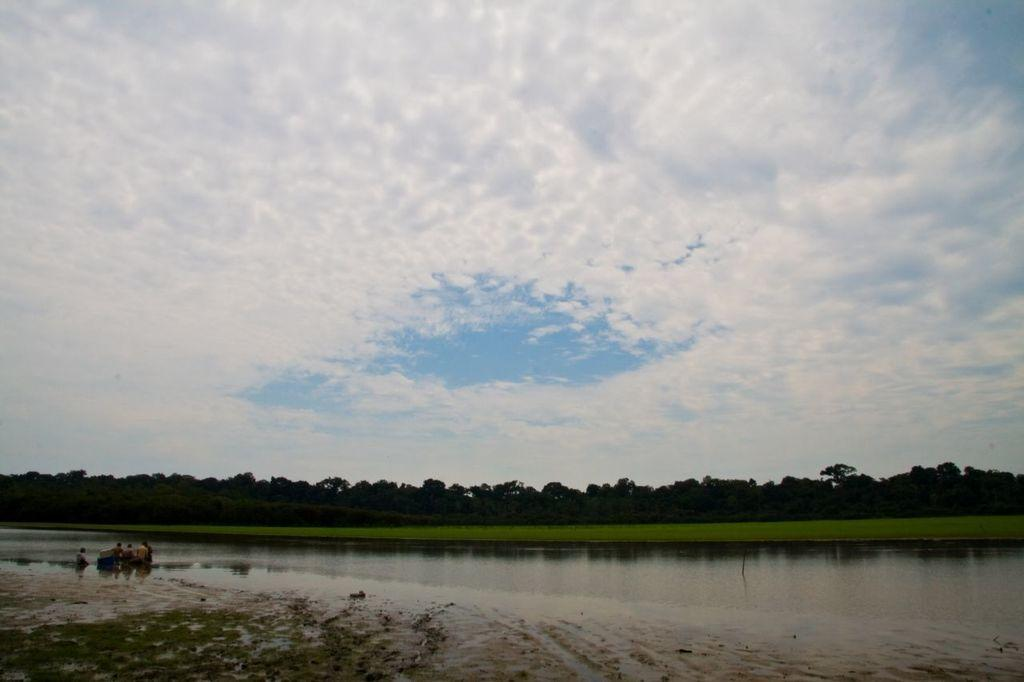What is present in the foreground of the image? In the foreground of the image, there is mud, grass, and water. What are the people in the image doing? There are persons in the water, suggesting they might be swimming or playing. What can be seen in the background of the image? In the background of the image, there is grass, trees, and sky visible. What is the condition of the sky in the image? The sky is visible in the background of the image, and there are clouds present. What type of lace can be seen on the persons in the water? There is no lace visible on the persons in the water; they are likely wearing swimsuits or casual clothing. Can you tell me how many drawers are present in the image? There are no drawers present in the image; it features a natural outdoor scene with water, mud, grass, trees, and sky. 